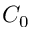<formula> <loc_0><loc_0><loc_500><loc_500>C _ { 0 }</formula> 